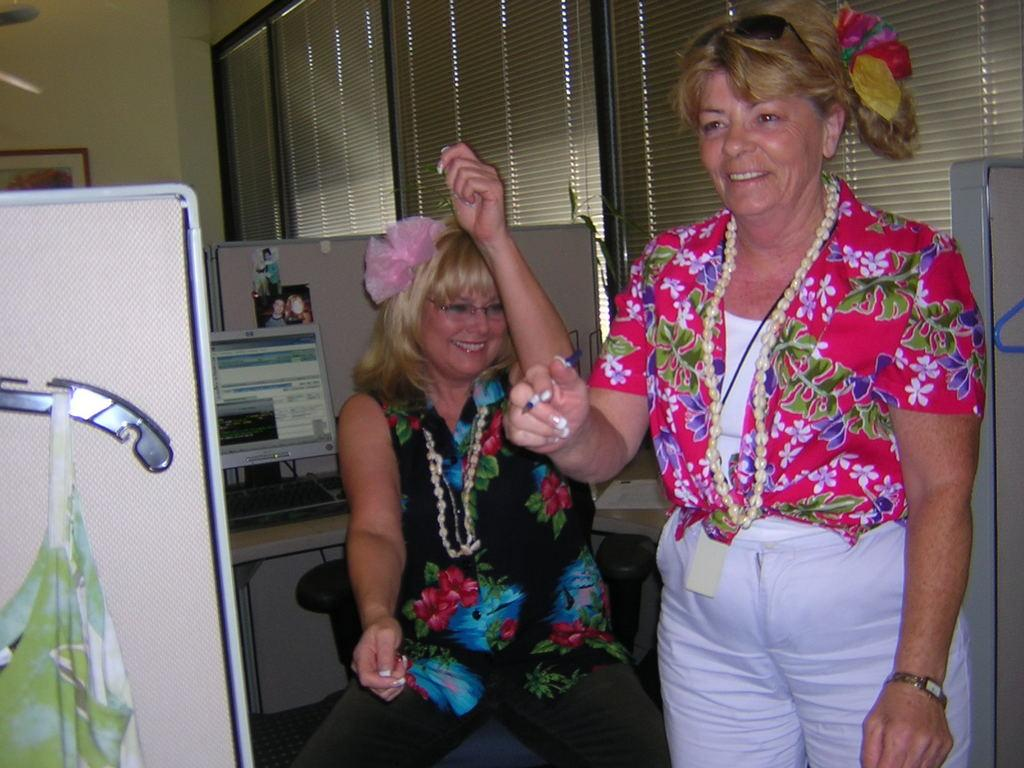Who is the main subject in the image? There are women in the center of the image. What objects can be seen in the background? There is a monitor, a keyboard, photographs, cabins, windows, a curtain, a photo frame, and a wall in the background. What type of furniture or equipment is present in the background? The monitor and keyboard suggest that there might be a desk or workstation in the background. What is the purpose of the curtain in the image? The curtain is associated with the windows, which suggests it is used for privacy or light control. How many baskets are visible in the image? There are no baskets visible baskets in the image. What type of station is shown in the image? There is no station present in the image. 